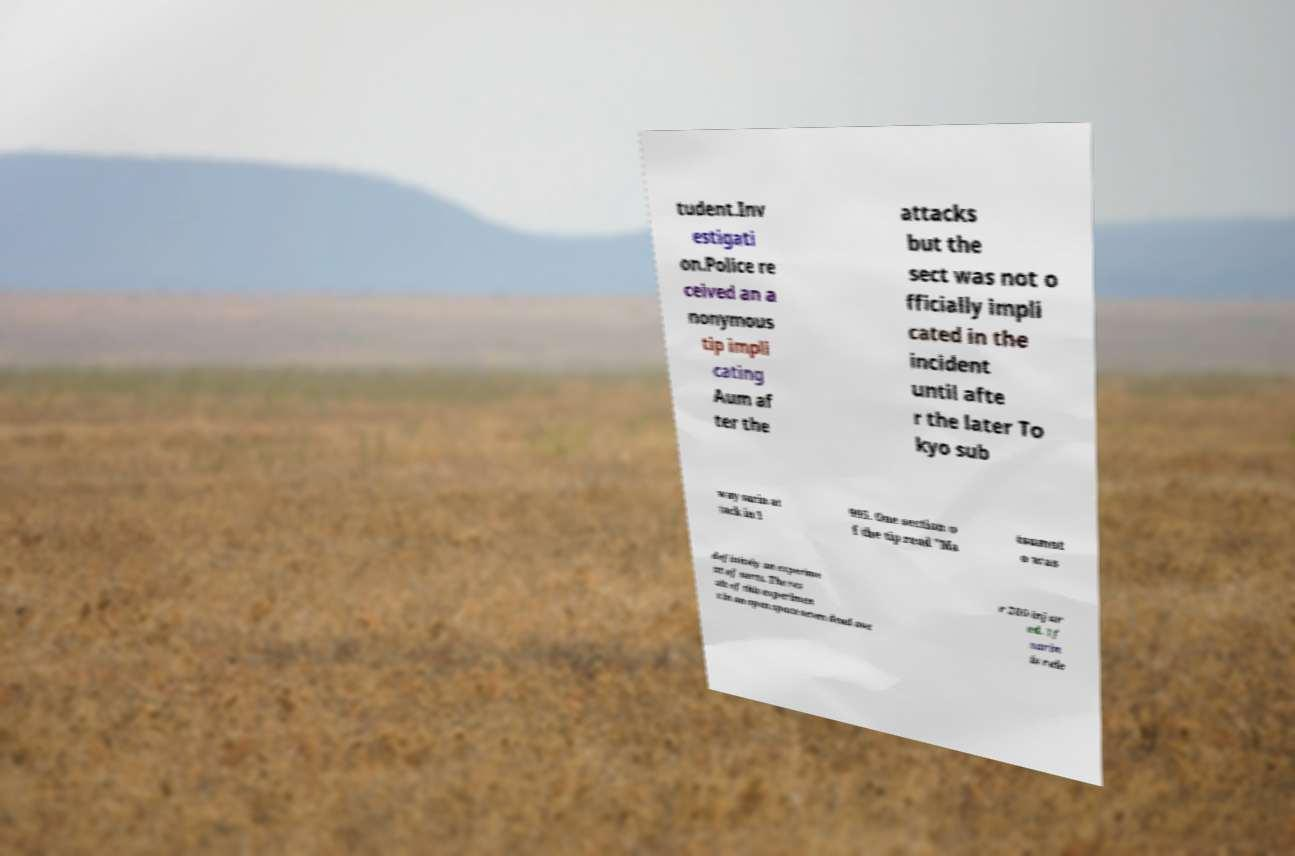For documentation purposes, I need the text within this image transcribed. Could you provide that? tudent.Inv estigati on.Police re ceived an a nonymous tip impli cating Aum af ter the attacks but the sect was not o fficially impli cated in the incident until afte r the later To kyo sub way sarin at tack in 1 995. One section o f the tip read "Ma tsumot o was definitely an experime nt of sorts. The res ult of this experimen t in an open space seven dead ove r 200 injur ed. If sarin is rele 